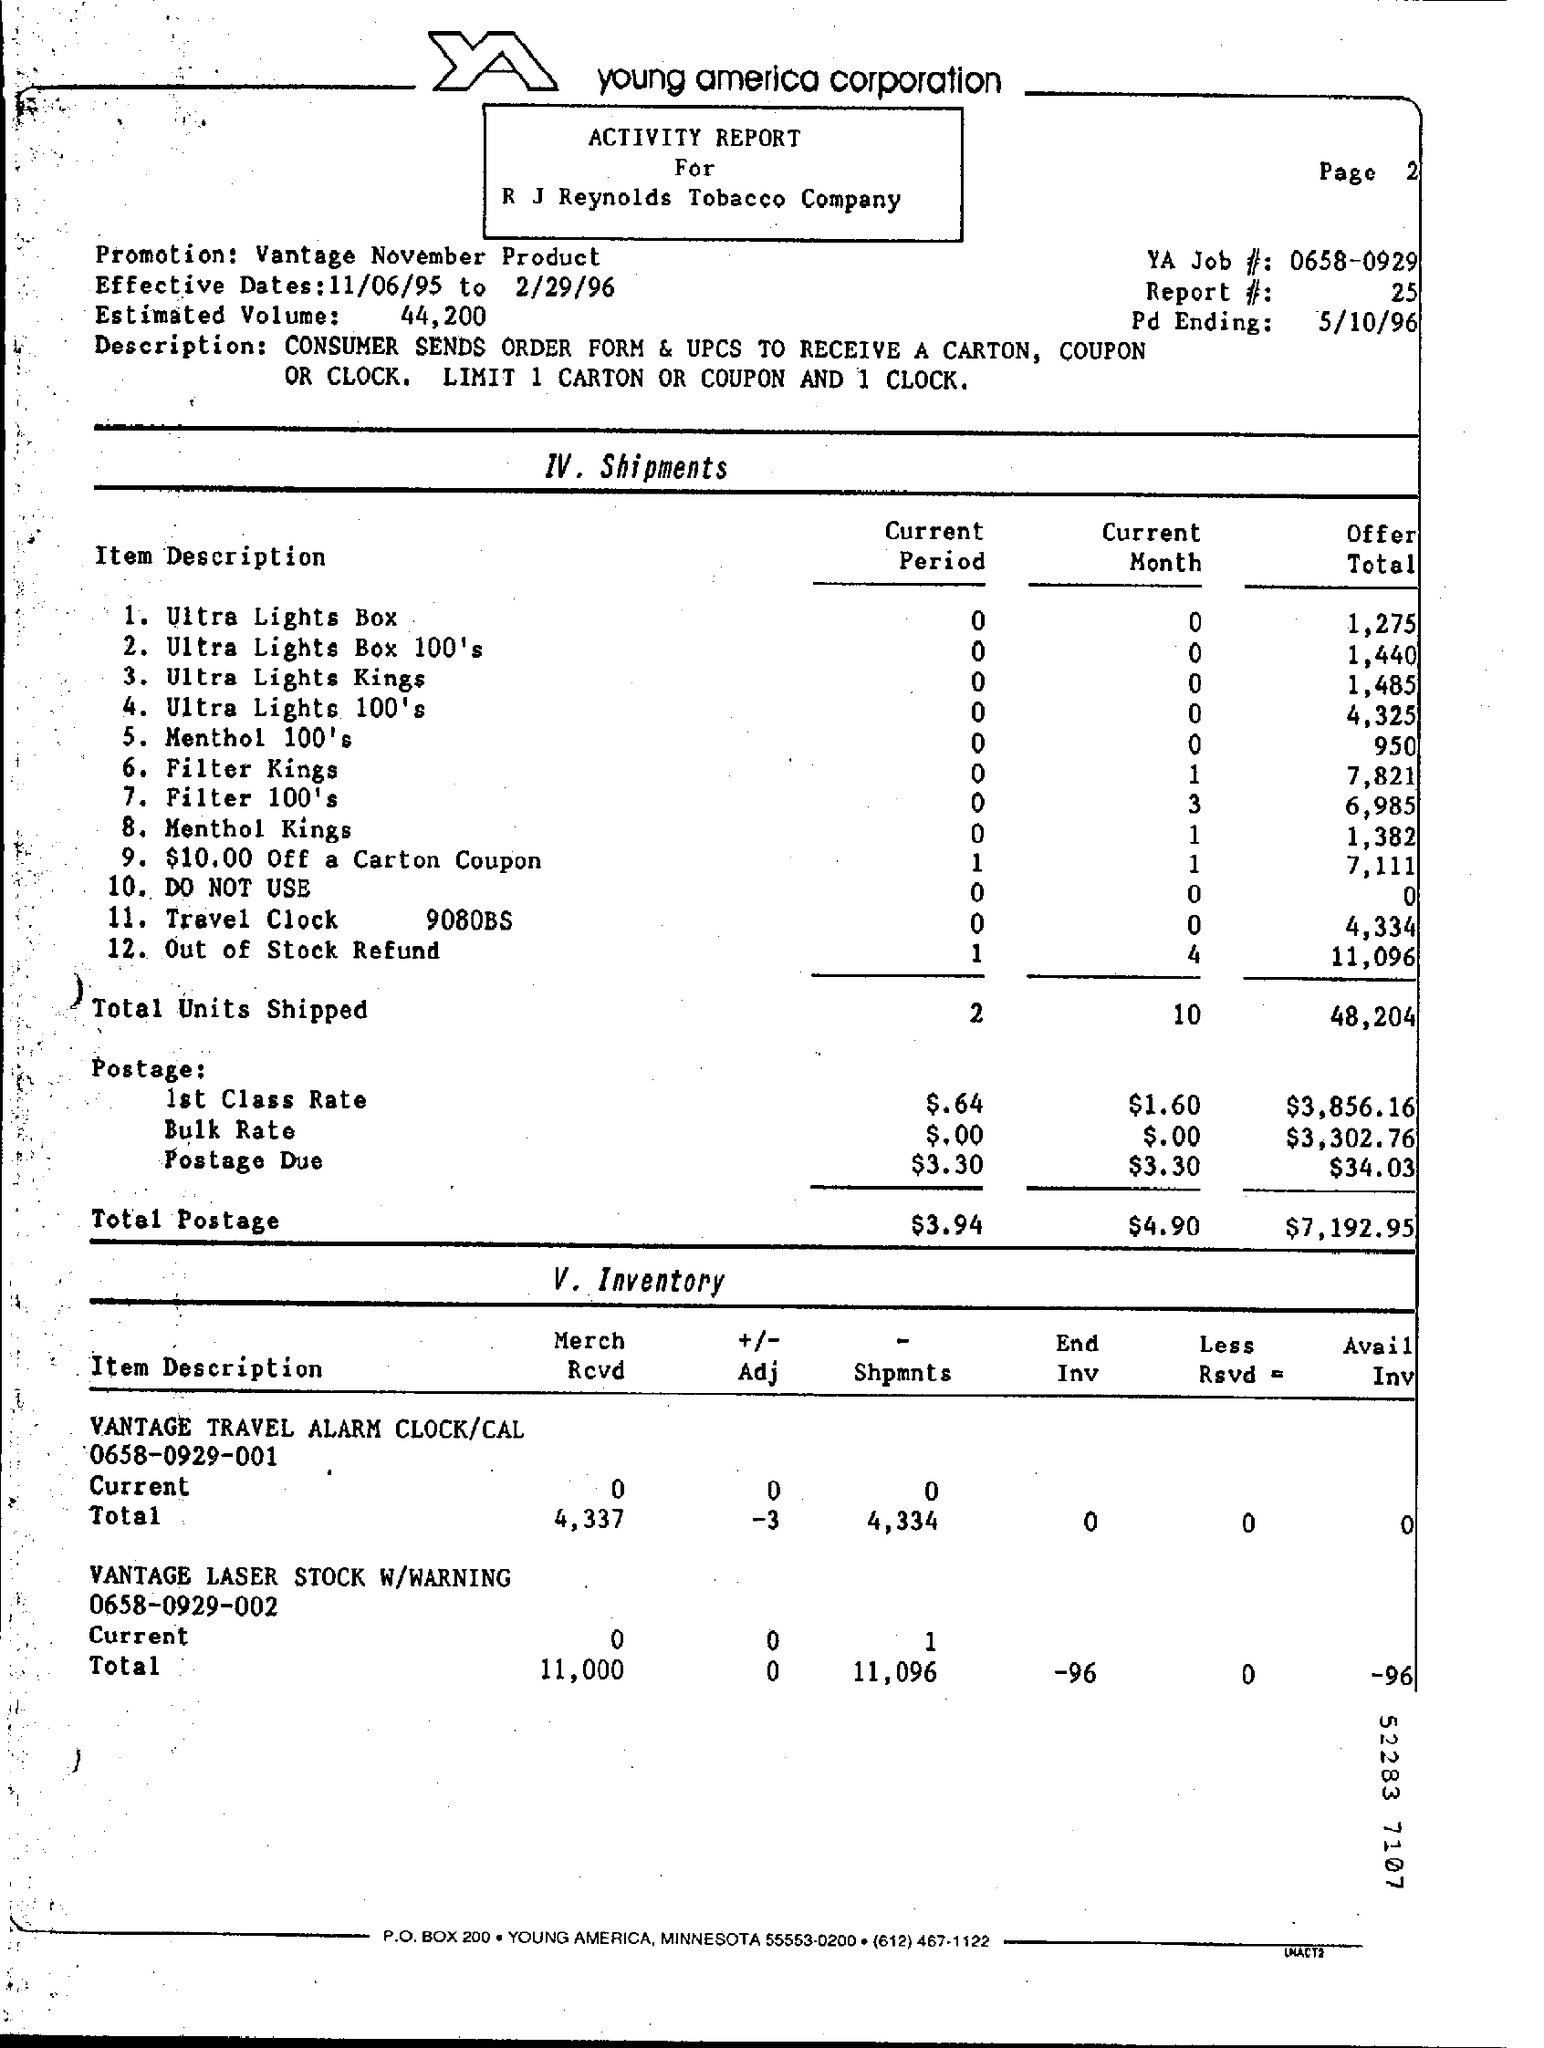What are the Effective Dates?
Offer a terse response. 11/06/95 TO 2/29/96. What is the Estimated Volume?
Offer a very short reply. 44,200. What is the YA Job#?
Offer a very short reply. 0658-0929. What is the Report#/
Provide a short and direct response. 25. What is the Pd Ending?
Give a very brief answer. 5/10/96. What is the Total Units shipped for Offer Total?
Offer a terse response. 48,204. 